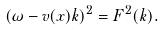Convert formula to latex. <formula><loc_0><loc_0><loc_500><loc_500>( \omega - v ( x ) k ) ^ { 2 } = F ^ { 2 } ( k ) .</formula> 